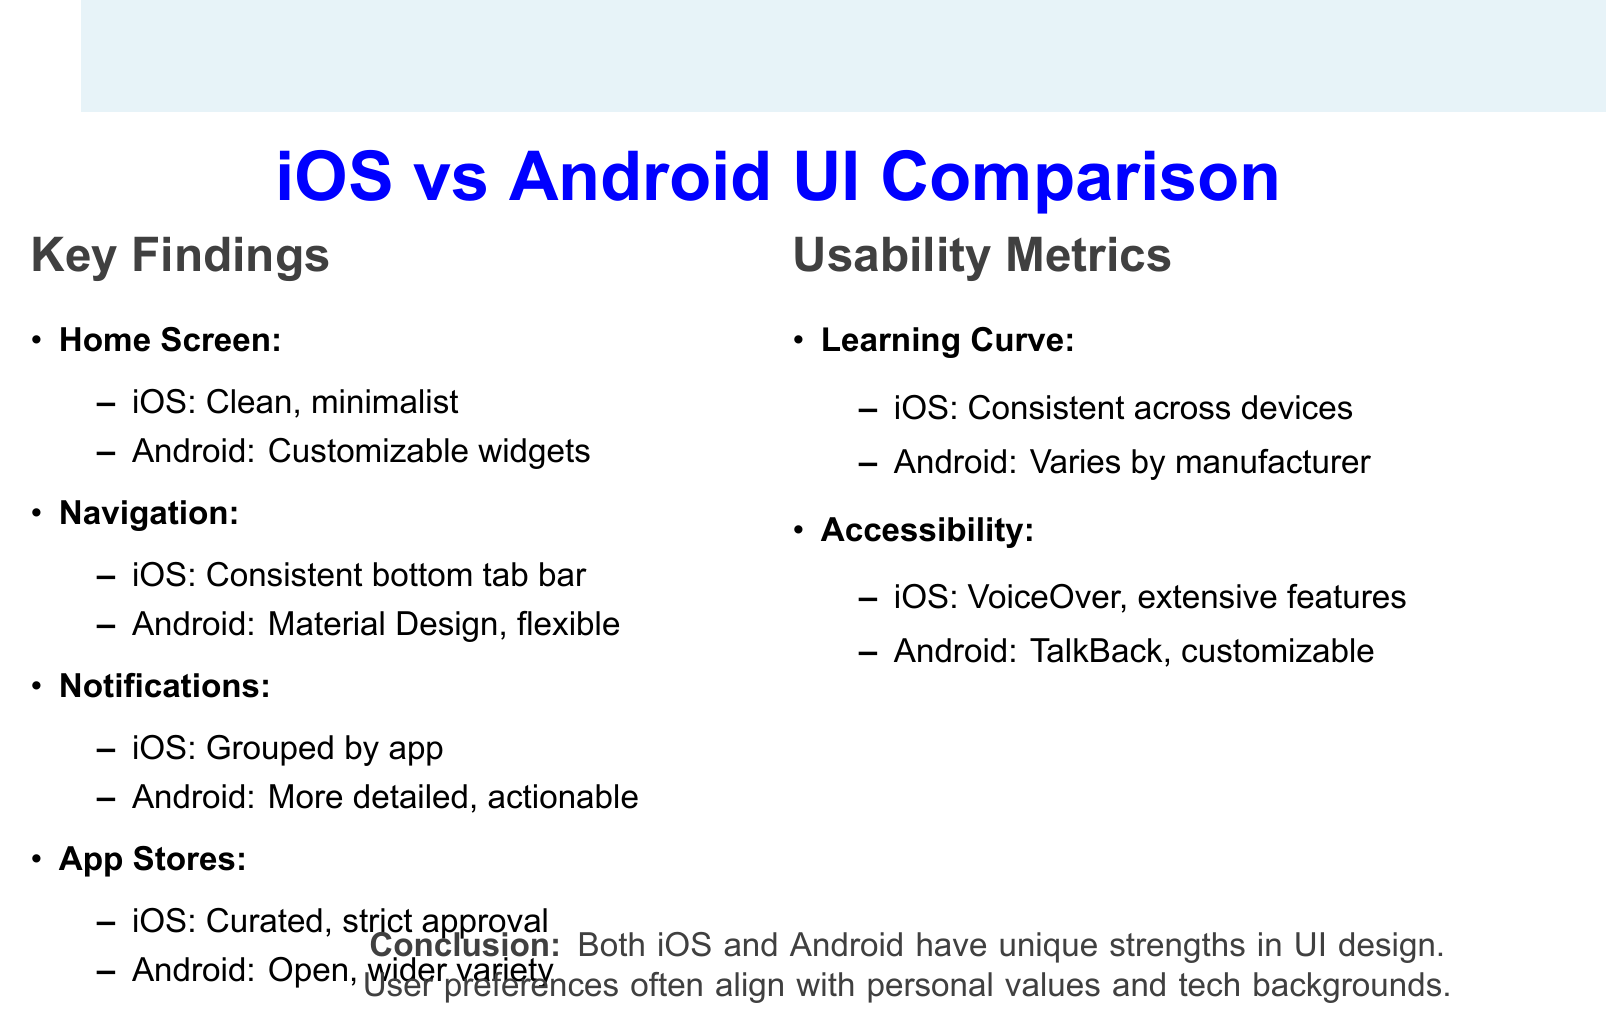What are the two operating systems compared in the study? The study compares user interfaces of iOS and Android.
Answer: iOS and Android Which home screen design is preferred by customization enthusiasts? Android's home screen design is known for customizable widgets and varied icon styles.
Answer: Android What navigation feature does iOS have that is mentioned in the document? iOS features a consistent bottom tab bar across most apps for navigation.
Answer: Bottom tab bar What type of app store does Android provide? Android's app store is described as open with a wider variety of apps available.
Answer: Open, wider variety Which operating system's notification management is generally preferred? Android's notifications are seen as more detailed and actionable, leading to user preference.
Answer: Android Which operating system has a steeper learning curve according to the usability metrics? The usability metric indicates that iOS has a steeper initial curve.
Answer: iOS What accessibility feature does iOS offer? iOS provides the VoiceOver feature along with extensive built-in accessibility features.
Answer: VoiceOver What is a key conclusion derived from the study? The conclusion emphasizes that both operating systems have unique strengths and that user preferences align with personal values and tech backgrounds.
Answer: Unique strengths in UI design 